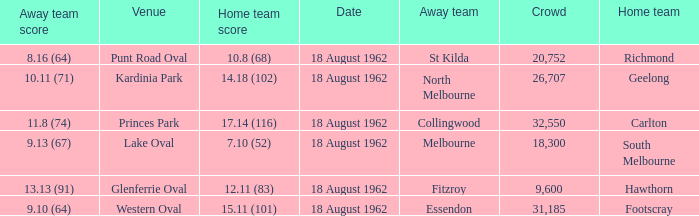Parse the table in full. {'header': ['Away team score', 'Venue', 'Home team score', 'Date', 'Away team', 'Crowd', 'Home team'], 'rows': [['8.16 (64)', 'Punt Road Oval', '10.8 (68)', '18 August 1962', 'St Kilda', '20,752', 'Richmond'], ['10.11 (71)', 'Kardinia Park', '14.18 (102)', '18 August 1962', 'North Melbourne', '26,707', 'Geelong'], ['11.8 (74)', 'Princes Park', '17.14 (116)', '18 August 1962', 'Collingwood', '32,550', 'Carlton'], ['9.13 (67)', 'Lake Oval', '7.10 (52)', '18 August 1962', 'Melbourne', '18,300', 'South Melbourne'], ['13.13 (91)', 'Glenferrie Oval', '12.11 (83)', '18 August 1962', 'Fitzroy', '9,600', 'Hawthorn'], ['9.10 (64)', 'Western Oval', '15.11 (101)', '18 August 1962', 'Essendon', '31,185', 'Footscray']]} What was the home team that scored 10.8 (68)? Richmond. 